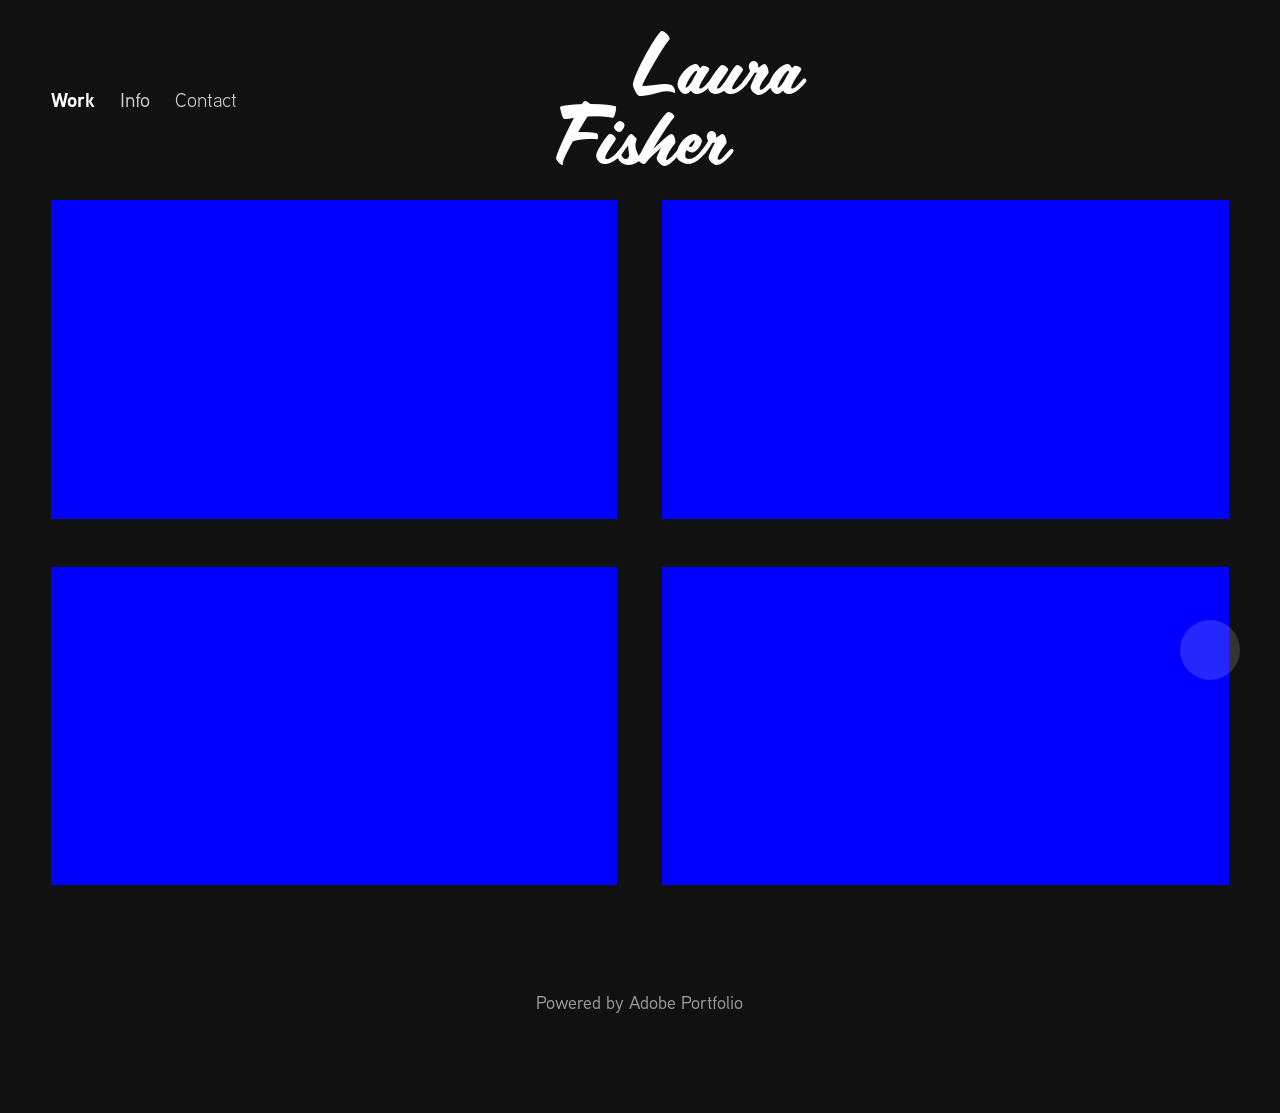What's the procedure for constructing this website from scratch with HTML? To build a website similar to the one depicted from scratch with HTML, you would start by structuring your HTML to define elements such as headers, navigation, main content areas (for projects or galleries), and a footer. Utilize <nav> for navigation links like 'Work', 'Info', and 'Contact'. Use <div> tags for organizing content sections and apply CSS for styling, such as setting background colors or aligning text. Additionally, consider responsive design aspects to ensure the site looks good on various devices. 